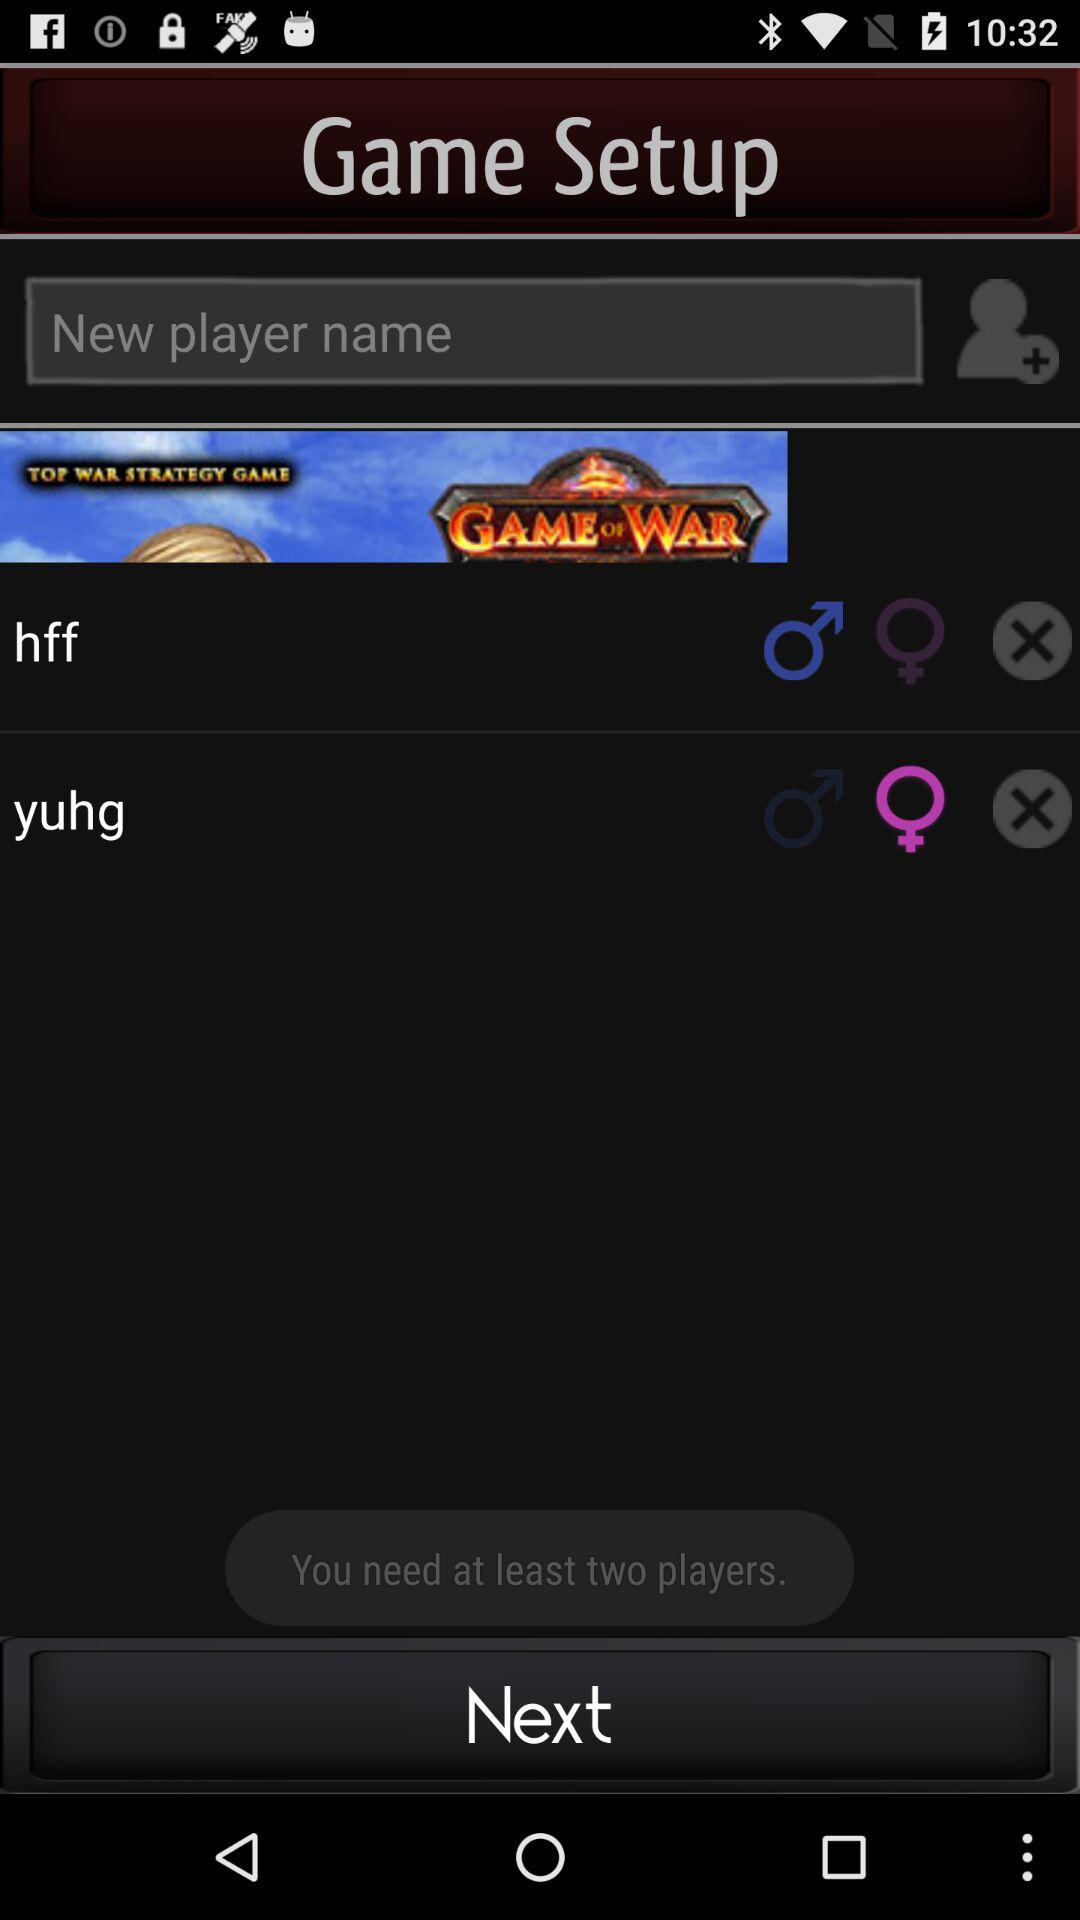What is the player name? The player names are "hff" and "yuhg". 